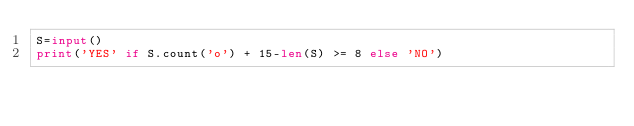Convert code to text. <code><loc_0><loc_0><loc_500><loc_500><_Python_>S=input()
print('YES' if S.count('o') + 15-len(S) >= 8 else 'NO')</code> 